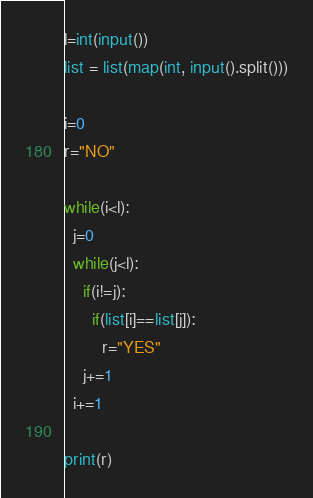<code> <loc_0><loc_0><loc_500><loc_500><_Python_>l=int(input())
list = list(map(int, input().split()))

i=0
r="NO"

while(i<l):
  j=0
  while(j<l):
    if(i!=j):
      if(list[i]==list[j]):
        r="YES"
    j+=1
  i+=1

print(r)</code> 